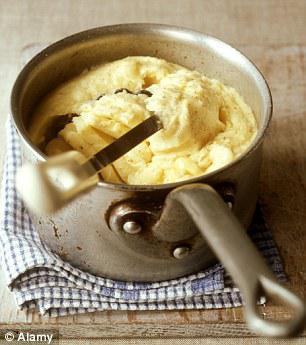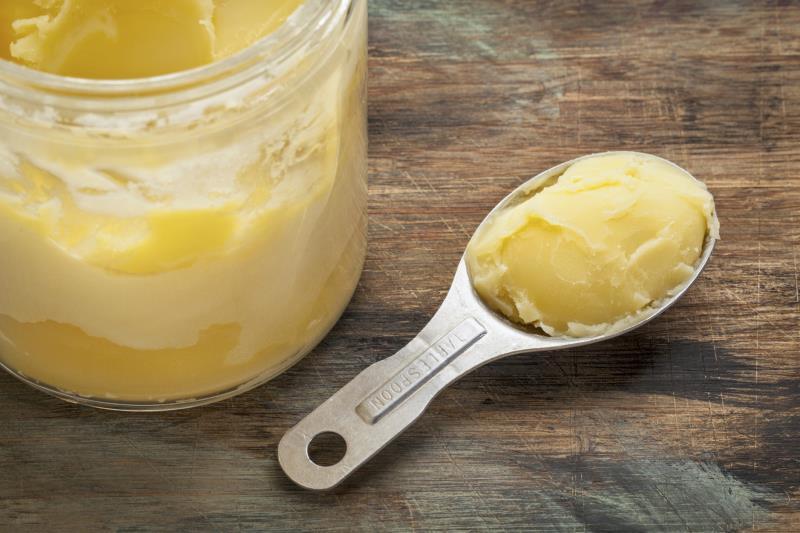The first image is the image on the left, the second image is the image on the right. Examine the images to the left and right. Is the description "Right image shows a round solid-colored dish containing some type of meat item." accurate? Answer yes or no. No. The first image is the image on the left, the second image is the image on the right. Analyze the images presented: Is the assertion "A spoon sits by the food in one of the images." valid? Answer yes or no. Yes. 